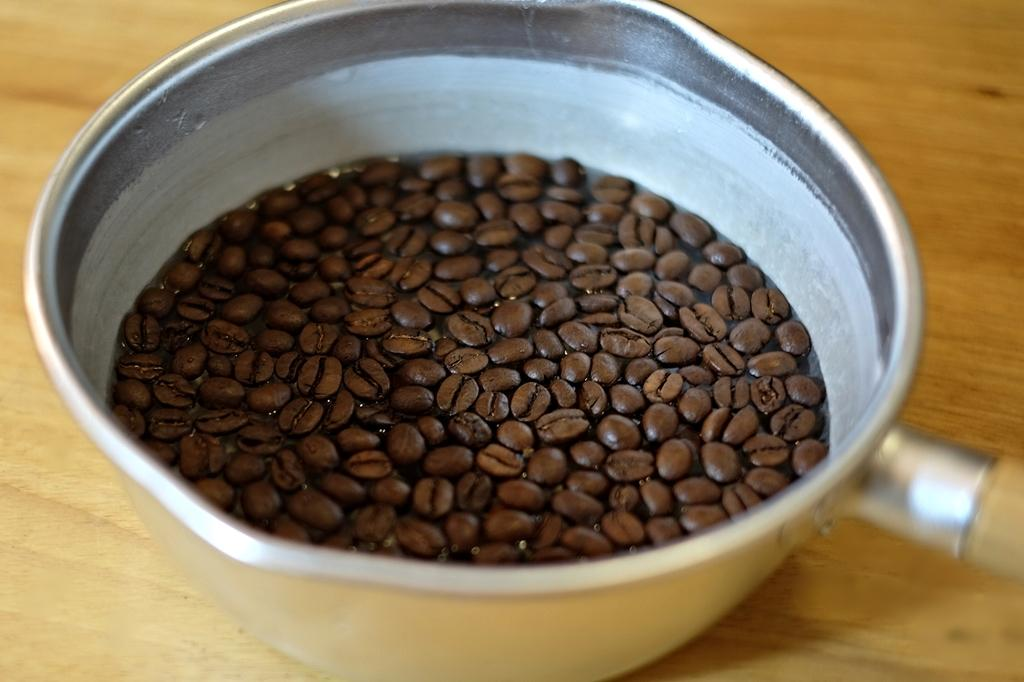What is the main subject of the image? The main subject of the image is coffee beans. How are the coffee beans contained in the image? The coffee beans are in a bowl. What is the surface on which the bowl is placed? The bowl is placed on a wooden surface. Reasoning: Leting: Let's think step by step in order to produce the conversation. We start by identifying the main subject of the image, which is the coffee beans. Then, we describe how the coffee beans are contained, which is in a bowl. Finally, we mention the surface on which the bowl is placed, which is a wooden surface. Each question is designed to elicit a specific detail about the image that is known from the provided facts. Absurd Question/Answer: How many basins are visible in the image? There are no basins present in the image; it features coffee beans in a bowl on a wooden surface. How much water can be stored in the basin shown in the image? There is no basin present in the image; it features coffee beans in a bowl on a wooden surface. 